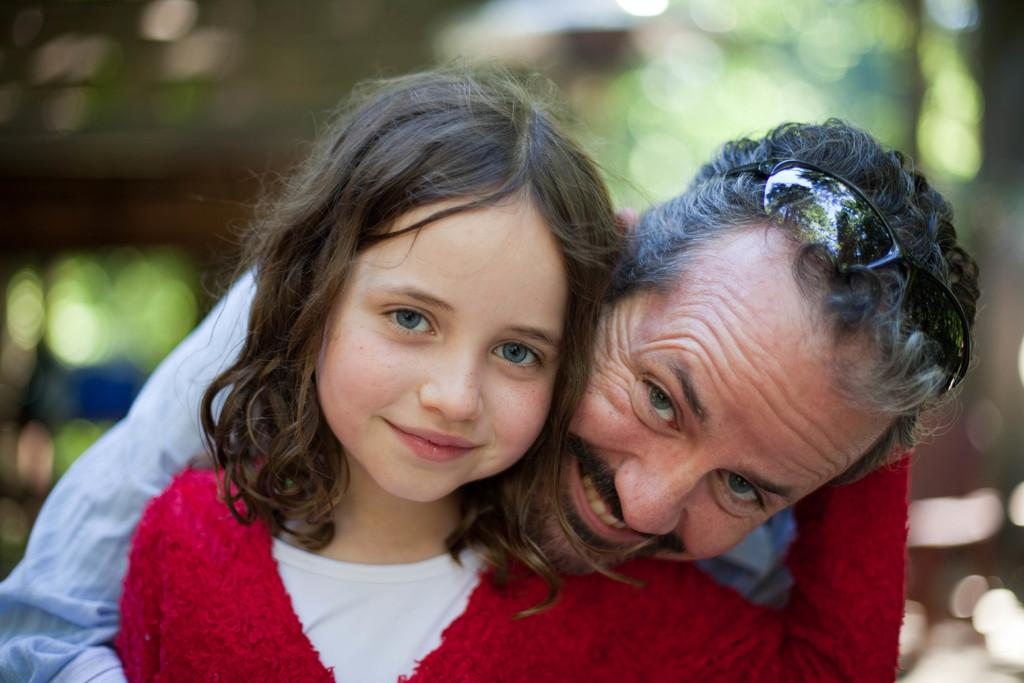Who is the main subject in the foreground of the image? There is a girl in the foreground of the image. What is the girl wearing? The girl is wearing a red dress. Can you describe the person behind the girl? There is a man behind the girl. How would you describe the background of the image? The background of the image is blurred. What type of veil is the girl wearing in the image? There is no veil present in the image; the girl is wearing a red dress. Can you tell me how many guns are visible in the image? There are no guns visible in the image. 